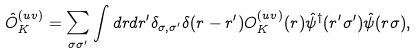<formula> <loc_0><loc_0><loc_500><loc_500>\hat { O } ^ { ( u v ) } _ { K } = \sum _ { \sigma \sigma ^ { \prime } } \int d r d r ^ { \prime } \delta _ { \sigma , \sigma ^ { \prime } } \delta ( r - r ^ { \prime } ) O ^ { ( u v ) } _ { K } ( r ) \hat { \psi } ^ { \dagger } ( r ^ { \prime } \sigma ^ { \prime } ) \hat { \psi } ( r \sigma ) ,</formula> 